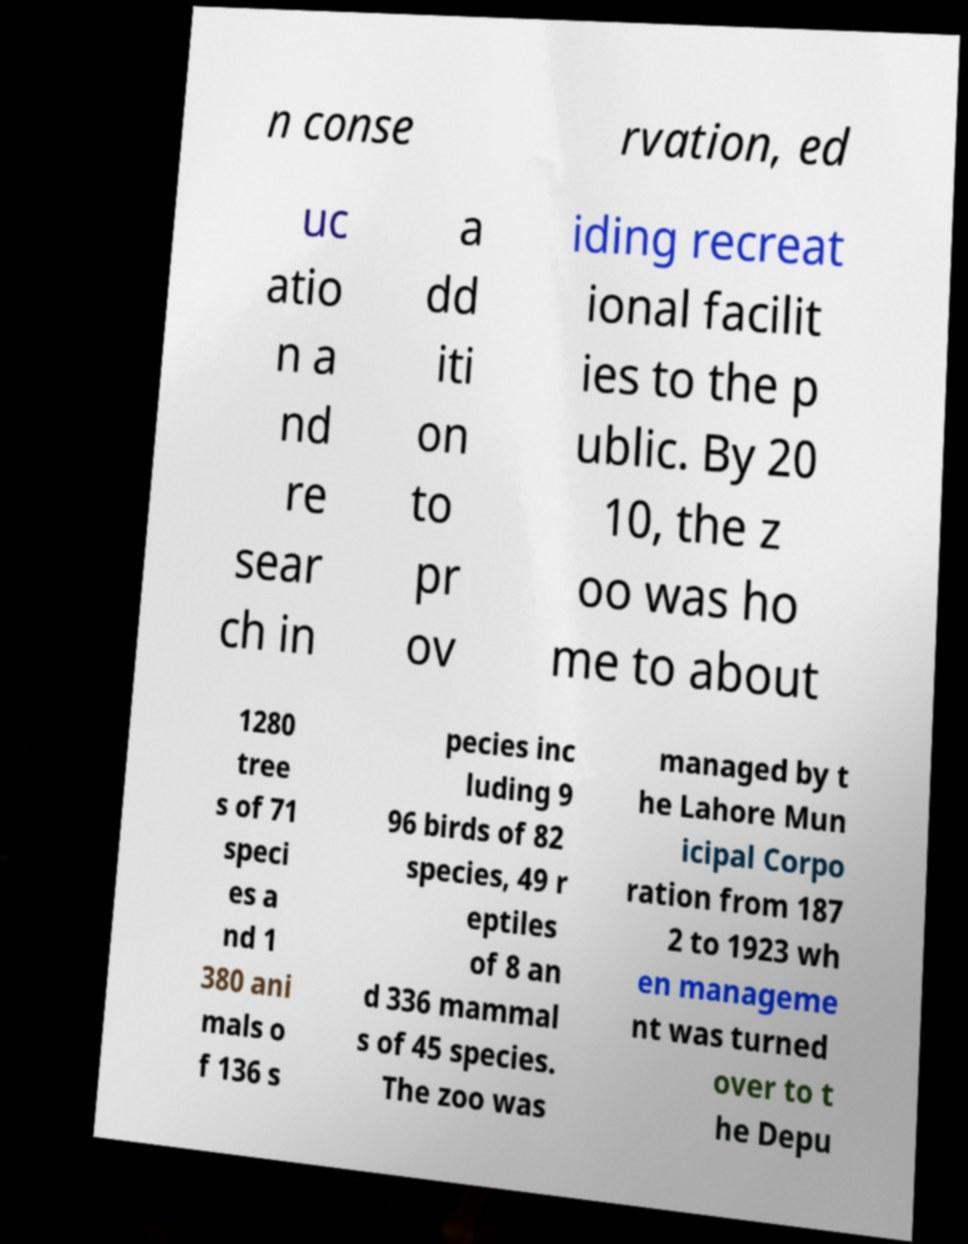Can you read and provide the text displayed in the image?This photo seems to have some interesting text. Can you extract and type it out for me? n conse rvation, ed uc atio n a nd re sear ch in a dd iti on to pr ov iding recreat ional facilit ies to the p ublic. By 20 10, the z oo was ho me to about 1280 tree s of 71 speci es a nd 1 380 ani mals o f 136 s pecies inc luding 9 96 birds of 82 species, 49 r eptiles of 8 an d 336 mammal s of 45 species. The zoo was managed by t he Lahore Mun icipal Corpo ration from 187 2 to 1923 wh en manageme nt was turned over to t he Depu 